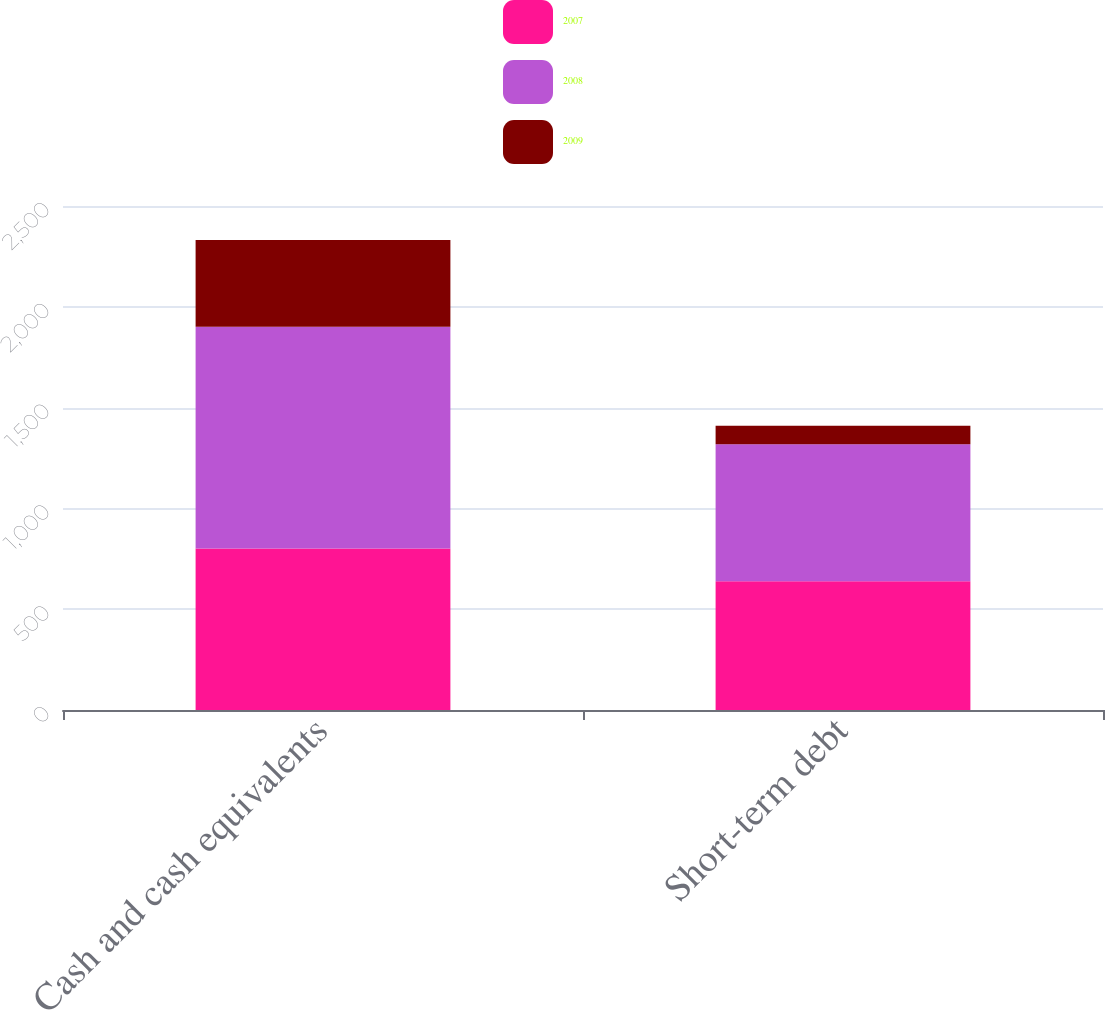<chart> <loc_0><loc_0><loc_500><loc_500><stacked_bar_chart><ecel><fcel>Cash and cash equivalents<fcel>Short-term debt<nl><fcel>2007<fcel>801<fcel>639<nl><fcel>2008<fcel>1100<fcel>679<nl><fcel>2009<fcel>430<fcel>92<nl></chart> 